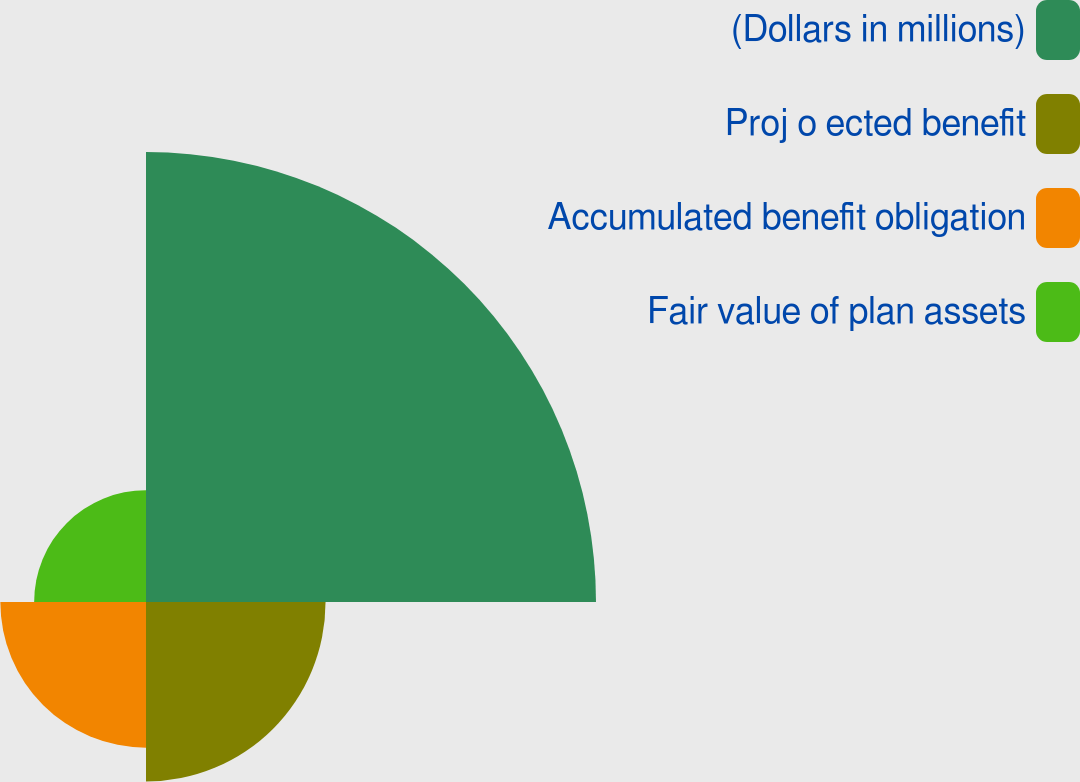<chart> <loc_0><loc_0><loc_500><loc_500><pie_chart><fcel>(Dollars in millions)<fcel>Proj o ected benefit<fcel>Accumulated benefit obligation<fcel>Fair value of plan assets<nl><fcel>50.73%<fcel>20.24%<fcel>16.42%<fcel>12.61%<nl></chart> 